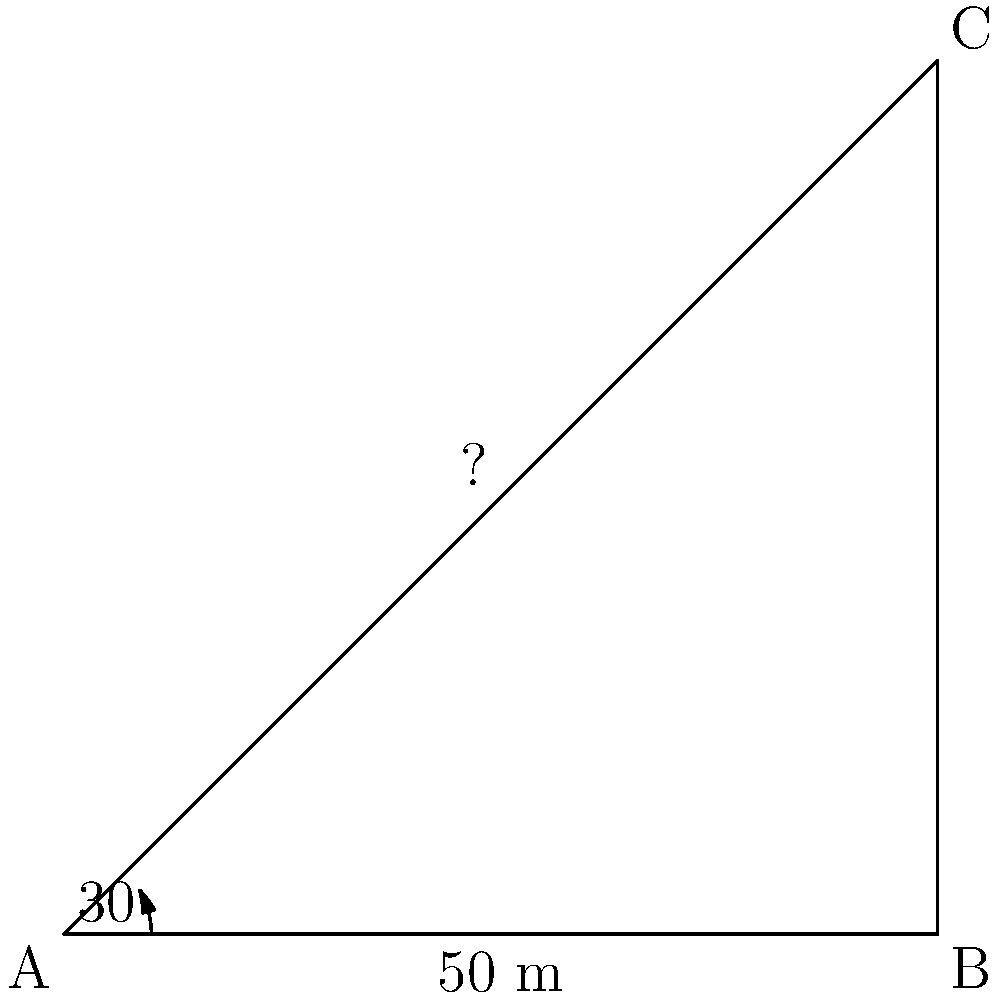Your coding club is working on a project to measure the height of a tall building on campus using trigonometry. You stand 50 meters away from the base of the building and use a clinometer to measure the angle of elevation to the top of the building, which is 30°. Using this information, calculate the height of the building to the nearest meter. Let's approach this step-by-step:

1) We can model this scenario as a right-angled triangle, where:
   - The base of the triangle is the distance from you to the building (50 m)
   - The height of the triangle is the height of the building (what we're solving for)
   - The angle between the base and the hypotenuse is 30°

2) In this right-angled triangle, we know:
   - The adjacent side (base) = 50 m
   - The angle = 30°
   - We need to find the opposite side (height)

3) This is a perfect scenario to use the tangent function. Recall:
   $\tan(\theta) = \frac{\text{opposite}}{\text{adjacent}}$

4) Let's plug in our known values:
   $\tan(30°) = \frac{\text{height}}{50}$

5) We can rearrange this to solve for height:
   $\text{height} = 50 \times \tan(30°)$

6) Now let's calculate:
   $\text{height} = 50 \times \tan(30°)$
   $= 50 \times 0.5773... $
   $= 28.8675...$

7) Rounding to the nearest meter:
   $\text{height} \approx 29$ meters
Answer: 29 meters 